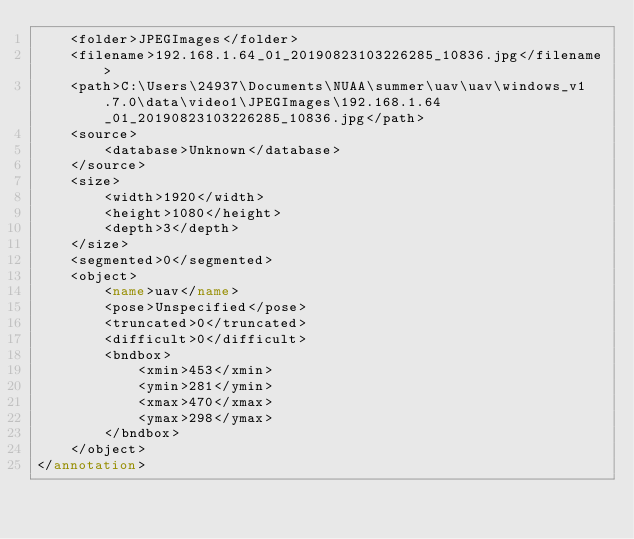<code> <loc_0><loc_0><loc_500><loc_500><_XML_>	<folder>JPEGImages</folder>
	<filename>192.168.1.64_01_20190823103226285_10836.jpg</filename>
	<path>C:\Users\24937\Documents\NUAA\summer\uav\uav\windows_v1.7.0\data\video1\JPEGImages\192.168.1.64_01_20190823103226285_10836.jpg</path>
	<source>
		<database>Unknown</database>
	</source>
	<size>
		<width>1920</width>
		<height>1080</height>
		<depth>3</depth>
	</size>
	<segmented>0</segmented>
	<object>
		<name>uav</name>
		<pose>Unspecified</pose>
		<truncated>0</truncated>
		<difficult>0</difficult>
		<bndbox>
			<xmin>453</xmin>
			<ymin>281</ymin>
			<xmax>470</xmax>
			<ymax>298</ymax>
		</bndbox>
	</object>
</annotation>
</code> 